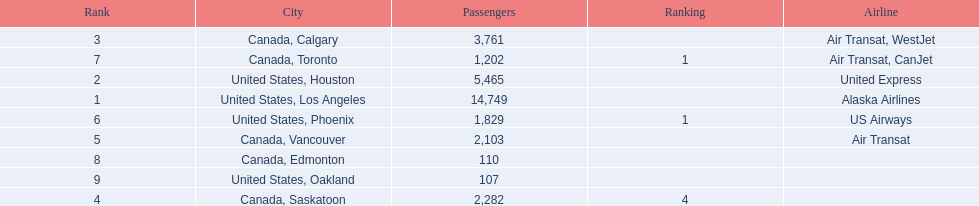Can you give me this table as a dict? {'header': ['Rank', 'City', 'Passengers', 'Ranking', 'Airline'], 'rows': [['3', 'Canada, Calgary', '3,761', '', 'Air Transat, WestJet'], ['7', 'Canada, Toronto', '1,202', '1', 'Air Transat, CanJet'], ['2', 'United States, Houston', '5,465', '', 'United Express'], ['1', 'United States, Los Angeles', '14,749', '', 'Alaska Airlines'], ['6', 'United States, Phoenix', '1,829', '1', 'US Airways'], ['5', 'Canada, Vancouver', '2,103', '', 'Air Transat'], ['8', 'Canada, Edmonton', '110', '', ''], ['9', 'United States, Oakland', '107', '', ''], ['4', 'Canada, Saskatoon', '2,282', '4', '']]} Los angeles and what other city had about 19,000 passenger combined Canada, Calgary. 